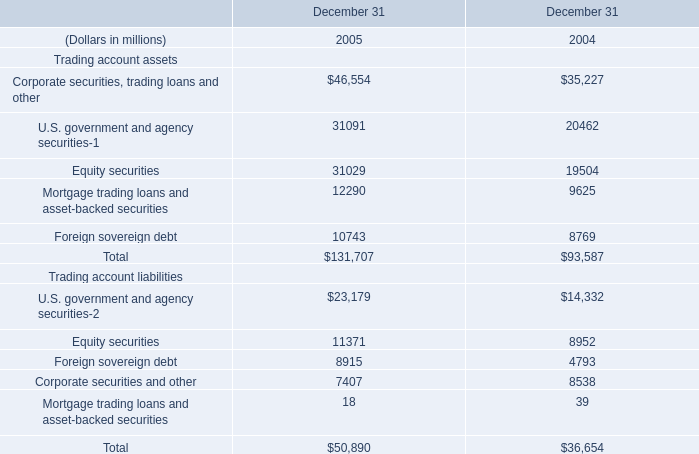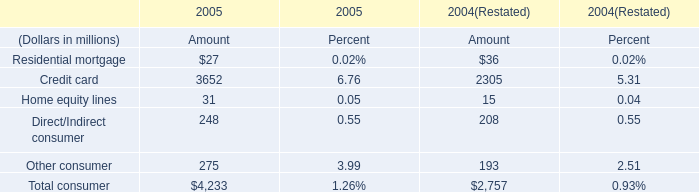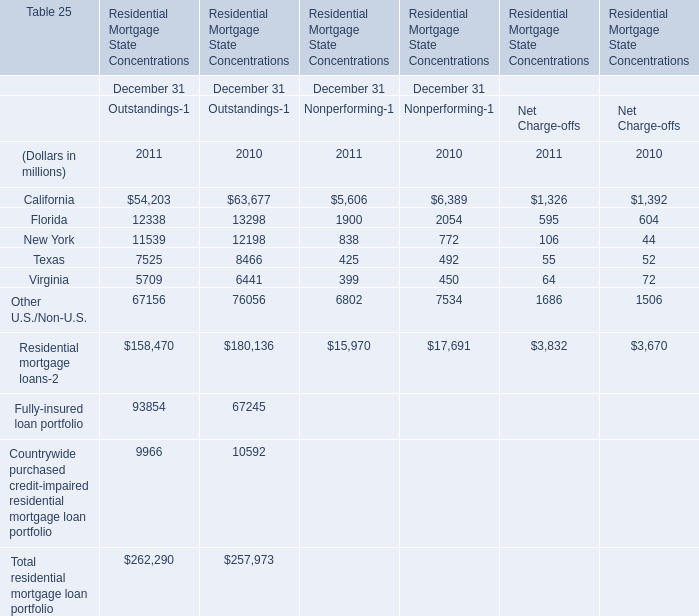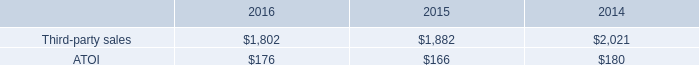considering the years 2015-2016 , what was the variation observed in the growth of the atoi in the transportation and construction solutions engineered products and solutions segments? 
Computations: (8% - 6%)
Answer: 0.02. 